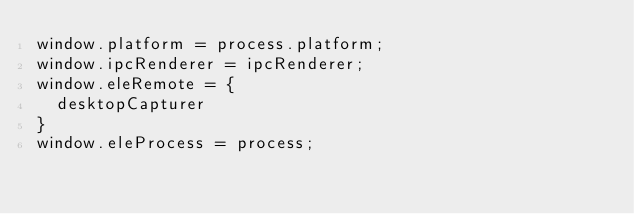Convert code to text. <code><loc_0><loc_0><loc_500><loc_500><_JavaScript_>window.platform = process.platform;
window.ipcRenderer = ipcRenderer;
window.eleRemote = {
  desktopCapturer
}
window.eleProcess = process;
</code> 